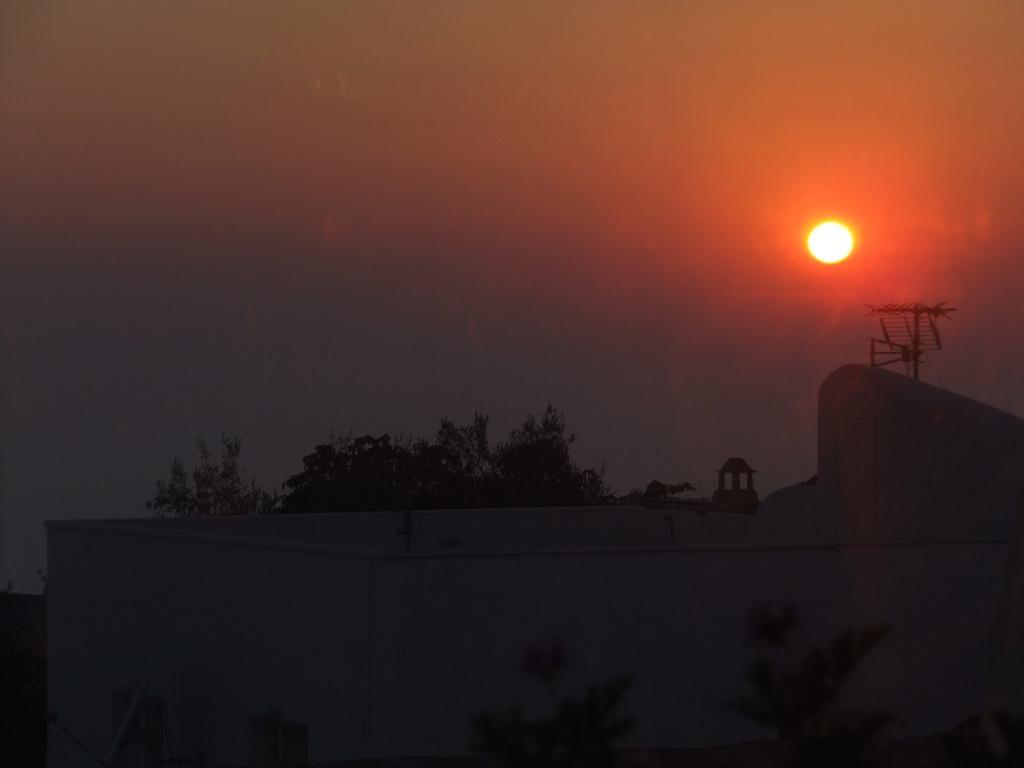Can you describe this image briefly? In the picture we can see a wall of the house near it, we can see some plants and on the top of the wall we can see a part of the tree and a pole and in the background we can see the sky with the sun. 